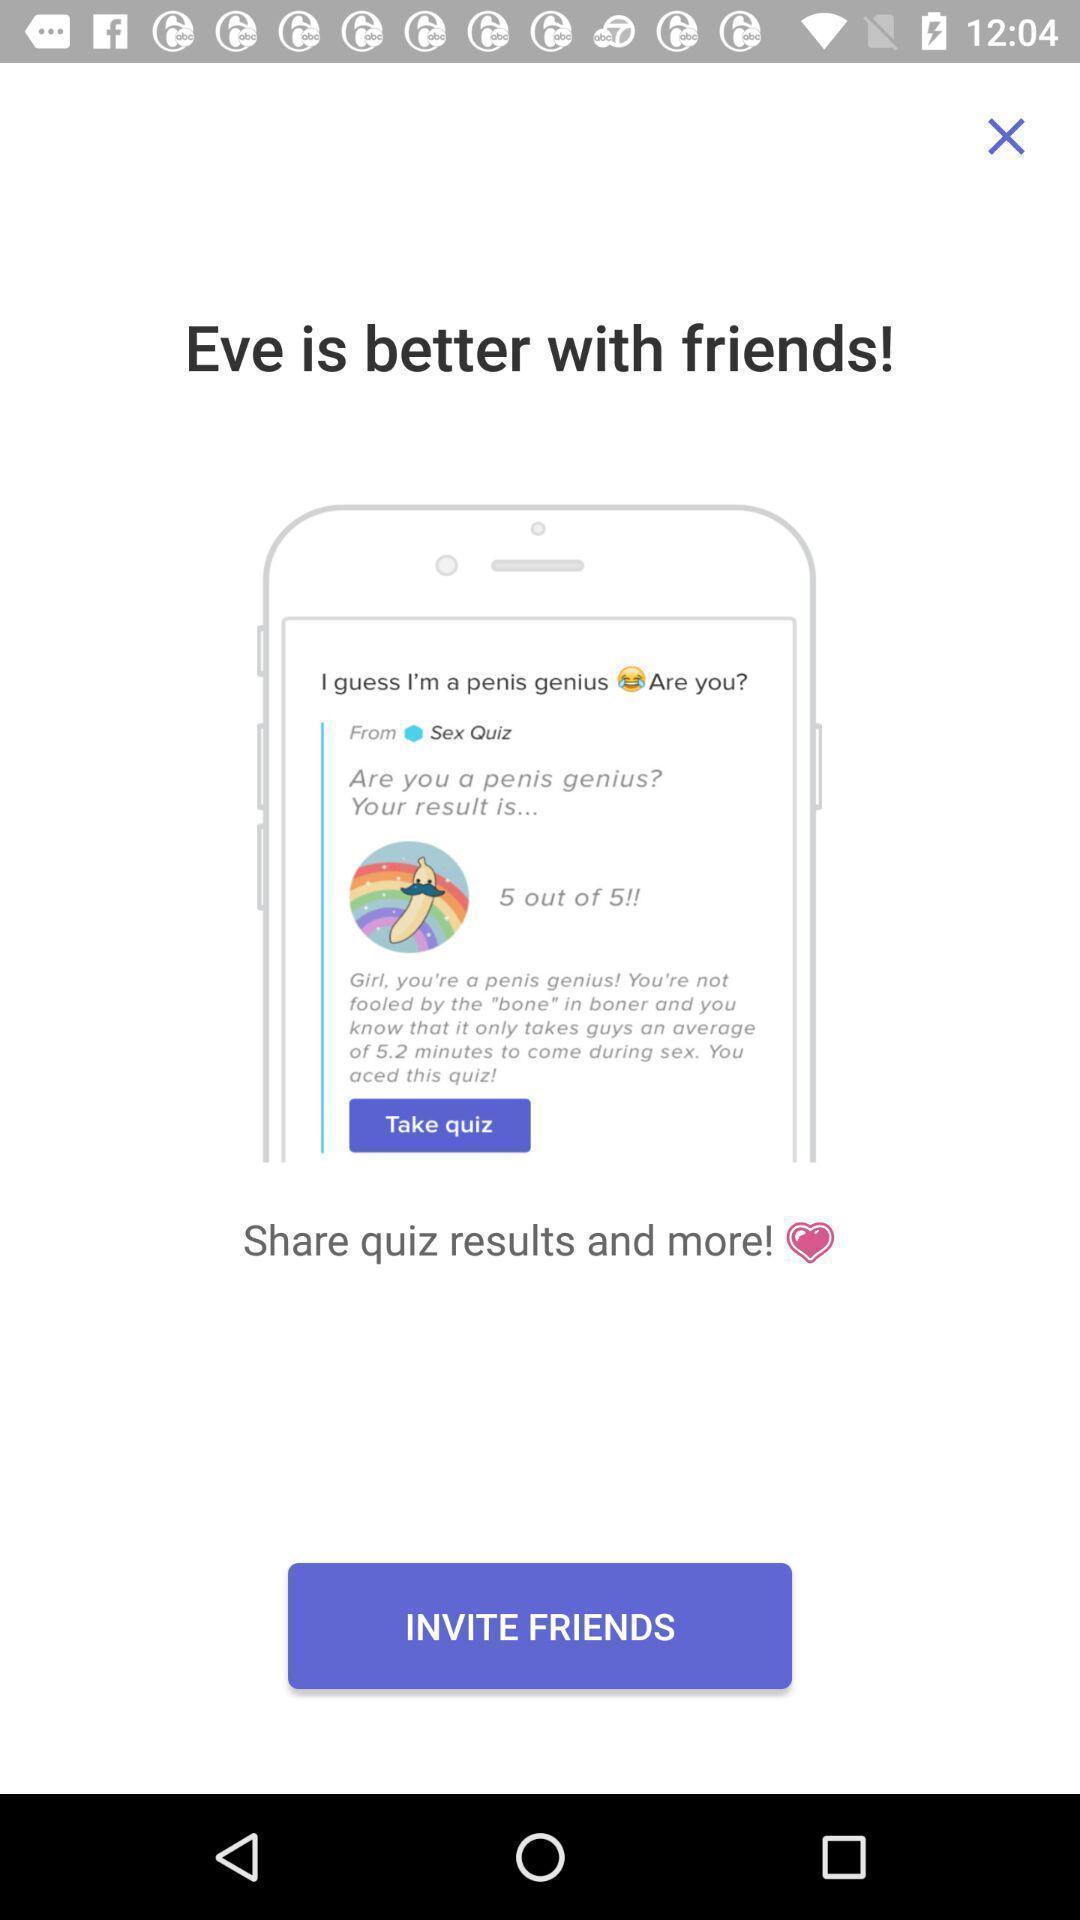Provide a textual representation of this image. Page for inviting friends of a social app. 